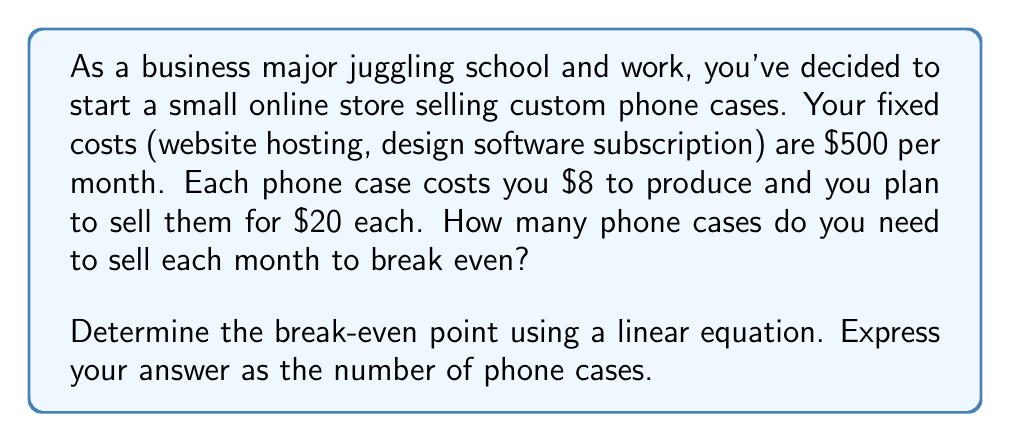Help me with this question. Let's approach this step-by-step using a linear equation:

1) First, let's define our variables:
   $x$ = number of phone cases sold
   $y$ = total revenue

2) We can express our total revenue ($y$) as a function of phone cases sold ($x$):
   $y = 20x$

3) Our total costs consist of fixed costs plus variable costs:
   Total Costs = Fixed Costs + (Variable Cost per Unit × Number of Units)
   $TC = 500 + 8x$

4) At the break-even point, total revenue equals total costs:
   $20x = 500 + 8x$

5) Now we can solve this equation:
   $20x - 8x = 500$
   $12x = 500$

6) Divide both sides by 12:
   $x = \frac{500}{12} = 41.67$

7) Since we can't sell a fraction of a phone case, we round up to the nearest whole number.
Answer: The break-even point is 42 phone cases. 